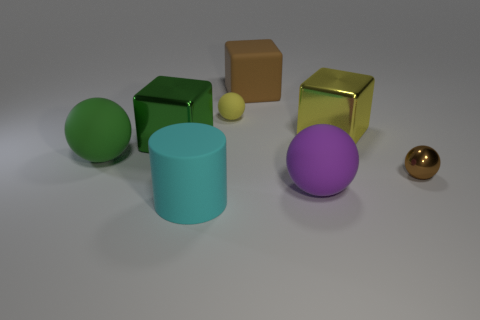Subtract 1 balls. How many balls are left? 3 Add 1 tiny purple metallic spheres. How many objects exist? 9 Subtract all cubes. How many objects are left? 5 Subtract all large matte cylinders. Subtract all rubber blocks. How many objects are left? 6 Add 3 big metallic cubes. How many big metallic cubes are left? 5 Add 1 matte blocks. How many matte blocks exist? 2 Subtract 0 blue blocks. How many objects are left? 8 